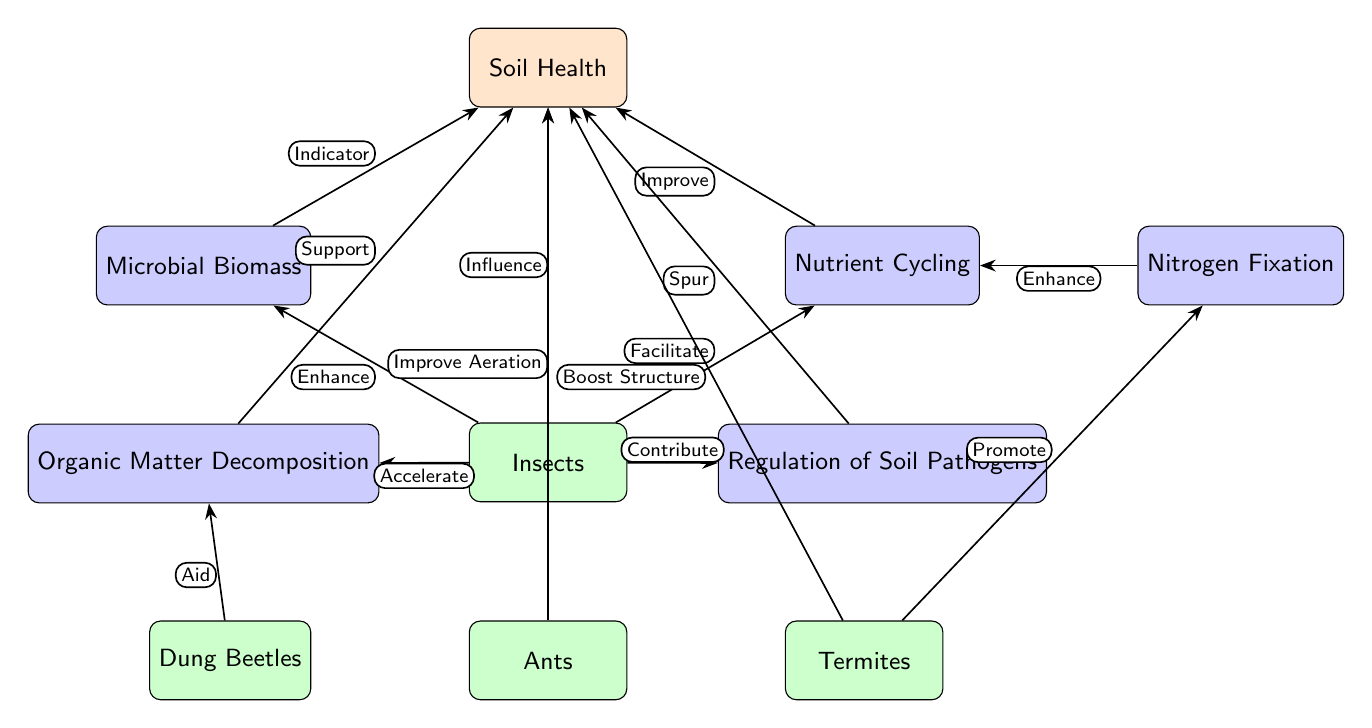What is the main subject of the diagram? The main subject (node) at the top of the diagram is labeled "Soil Health," indicating that the entire diagram focuses on this concept
Answer: Soil Health How many insect types are represented in the diagram? There are three insect types represented in the diagram: Dung Beetles, Ants, and Termites
Answer: Three What process directly follows Nutrient Cycling? The process that is connected to Nutrient Cycling and located to its right is Nitrogen Fixation
Answer: Nitrogen Fixation What is the role of Dung Beetles in the diagram? Dung Beetles are described as aiding in the Organic Matter Decomposition process, as indicated by the arrow and label "Aid" pointing to OMD
Answer: Aid Which insects are associated with improving soil health? Ants are linked to improving aeration in soil health and Termites boost soil structure, both contributing to the broader category of Soil Health
Answer: Ants and Termites How do insects influence Soil Health according to the diagram? Insects contribute to Soil Health directly and are shown with the edge labeled "Influence" pointing from Insects to Soil Health, indicating their impact
Answer: Influence Which process is accelerated by insects? Organic Matter Decomposition is the process that is confirmed to be accelerated by Insects, as indicated by the edge labeled "Accelerate"
Answer: Organic Matter Decomposition What do Termites promote in the ecosystem services as per the diagram? Termites promote Nitrogen Fixation, as indicated by the arrow from Termites to Nitrogen Fixation labeled "Promote"
Answer: Nitrogen Fixation What relationship exists between Microbial Biomass and Soil Health? Microbial Biomass serves as an indicator for Soil Health, as shown by the edge labeled "Indicator" pointing from Microbial Biomass to Soil Health
Answer: Indicator 